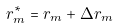<formula> <loc_0><loc_0><loc_500><loc_500>r ^ { * } _ { m } = r _ { m } + \Delta r _ { m }</formula> 